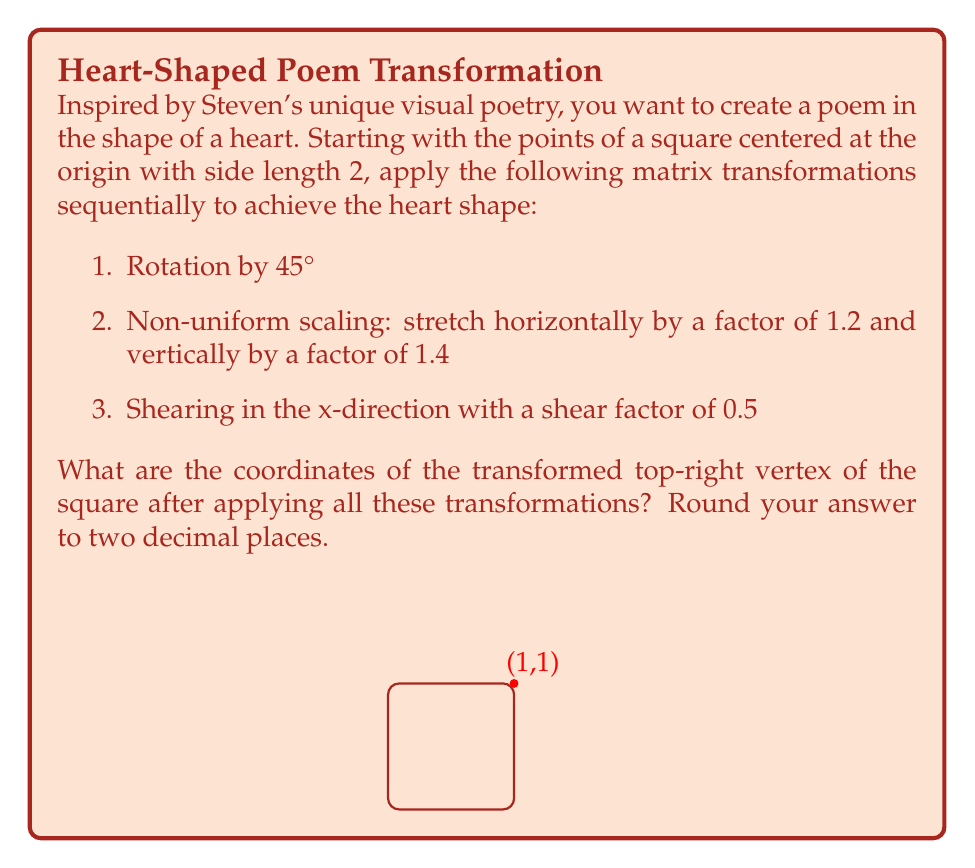Provide a solution to this math problem. Let's approach this step-by-step:

1) The initial top-right vertex of the square is at (1, 1).

2) Rotation by 45°:
   Rotation matrix: $$R = \begin{pmatrix} \cos 45° & -\sin 45° \\ \sin 45° & \cos 45° \end{pmatrix} = \begin{pmatrix} \frac{\sqrt{2}}{2} & -\frac{\sqrt{2}}{2} \\ \frac{\sqrt{2}}{2} & \frac{\sqrt{2}}{2} \end{pmatrix}$$
   
   $$\begin{pmatrix} \frac{\sqrt{2}}{2} & -\frac{\sqrt{2}}{2} \\ \frac{\sqrt{2}}{2} & \frac{\sqrt{2}}{2} \end{pmatrix} \begin{pmatrix} 1 \\ 1 \end{pmatrix} = \begin{pmatrix} 0 \\ \sqrt{2} \end{pmatrix}$$

3) Non-uniform scaling:
   Scaling matrix: $$S = \begin{pmatrix} 1.2 & 0 \\ 0 & 1.4 \end{pmatrix}$$
   
   $$\begin{pmatrix} 1.2 & 0 \\ 0 & 1.4 \end{pmatrix} \begin{pmatrix} 0 \\ \sqrt{2} \end{pmatrix} = \begin{pmatrix} 0 \\ 1.4\sqrt{2} \end{pmatrix}$$

4) Shearing in x-direction:
   Shear matrix: $$H = \begin{pmatrix} 1 & 0.5 \\ 0 & 1 \end{pmatrix}$$
   
   $$\begin{pmatrix} 1 & 0.5 \\ 0 & 1 \end{pmatrix} \begin{pmatrix} 0 \\ 1.4\sqrt{2} \end{pmatrix} = \begin{pmatrix} 0.7\sqrt{2} \\ 1.4\sqrt{2} \end{pmatrix}$$

5) Final coordinates:
   x = $0.7\sqrt{2} \approx 0.99$
   y = $1.4\sqrt{2} \approx 1.98$

Rounding to two decimal places: (0.99, 1.98)
Answer: (0.99, 1.98) 